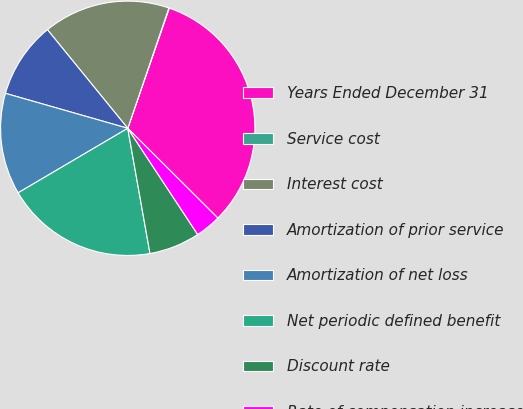Convert chart. <chart><loc_0><loc_0><loc_500><loc_500><pie_chart><fcel>Years Ended December 31<fcel>Service cost<fcel>Interest cost<fcel>Amortization of prior service<fcel>Amortization of net loss<fcel>Net periodic defined benefit<fcel>Discount rate<fcel>Rate of compensation increase<nl><fcel>32.18%<fcel>0.05%<fcel>16.12%<fcel>9.69%<fcel>12.9%<fcel>19.33%<fcel>6.47%<fcel>3.26%<nl></chart> 